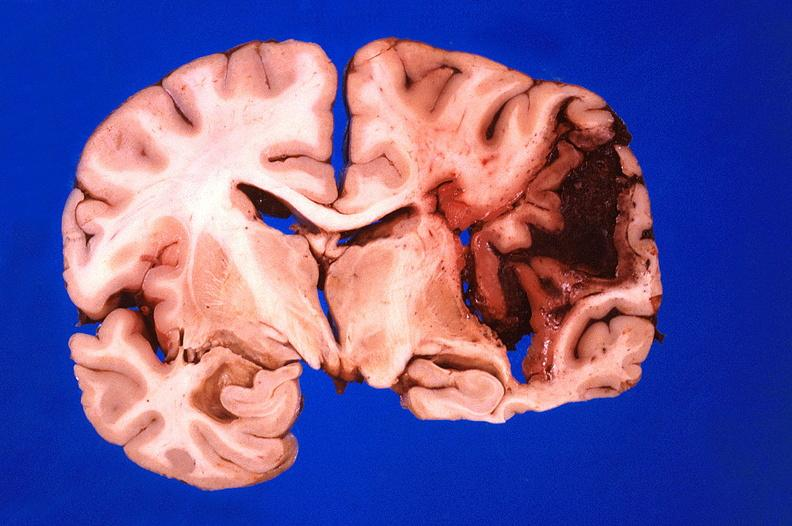s nervous present?
Answer the question using a single word or phrase. Yes 